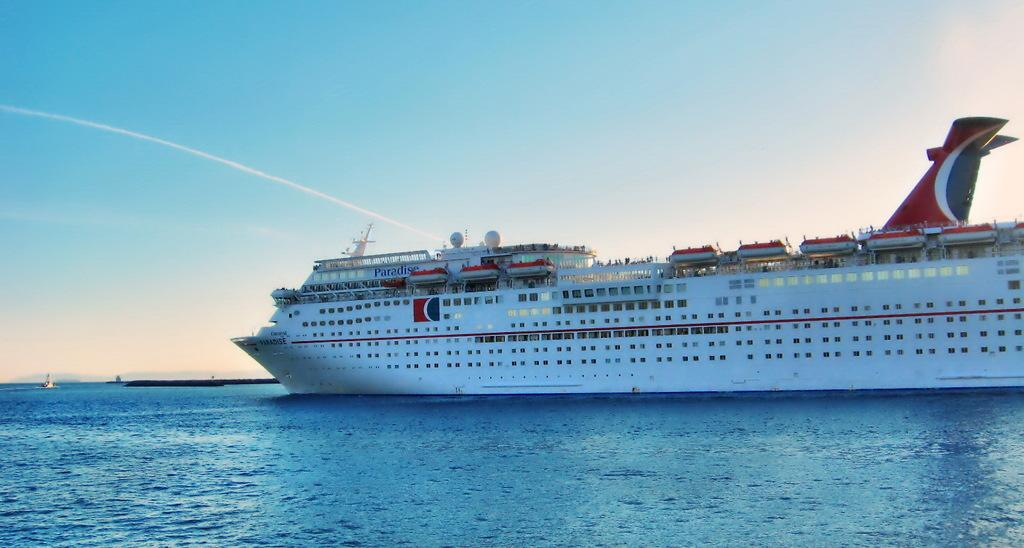<image>
Summarize the visual content of the image. An enormous Paradise cruise ship carries passengers on vacation. 